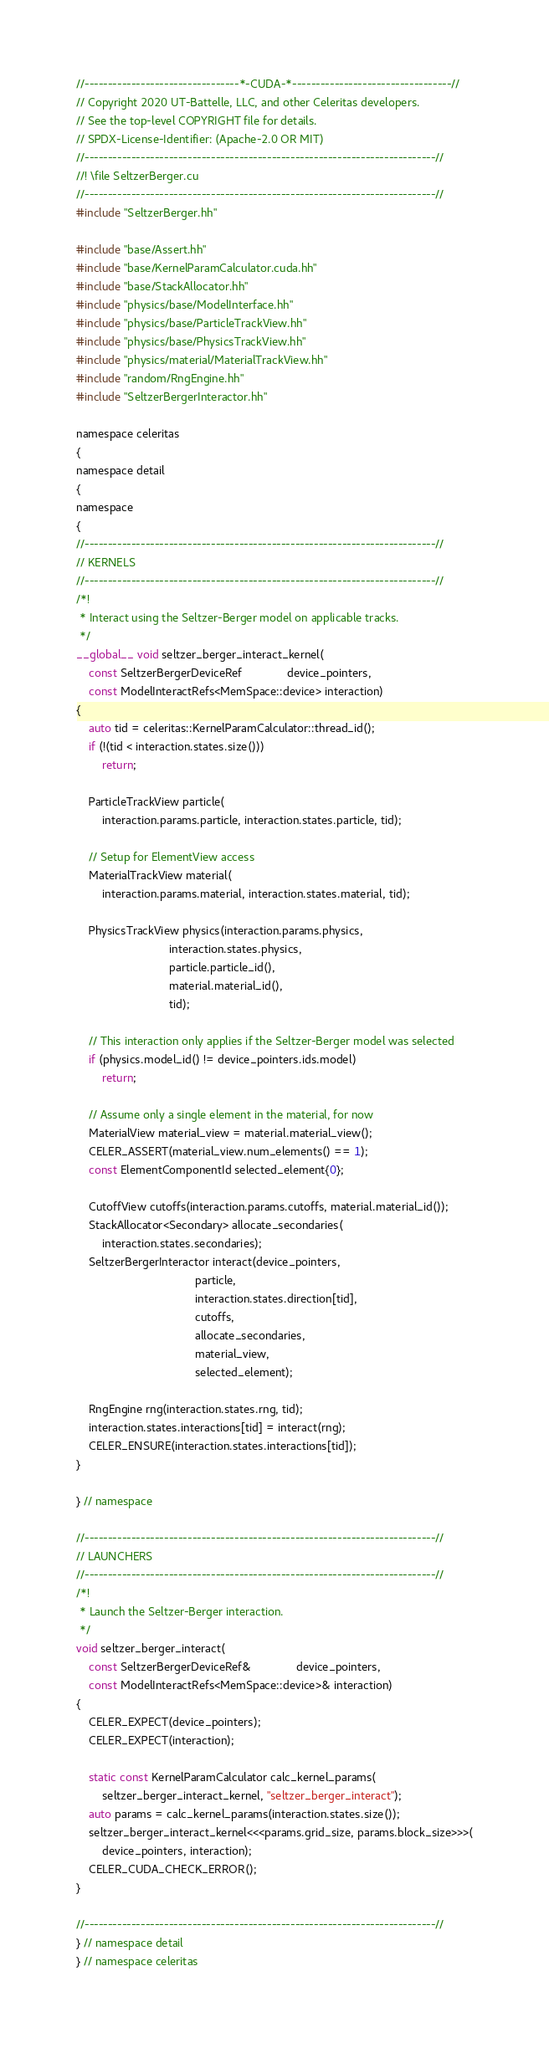<code> <loc_0><loc_0><loc_500><loc_500><_Cuda_>//---------------------------------*-CUDA-*----------------------------------//
// Copyright 2020 UT-Battelle, LLC, and other Celeritas developers.
// See the top-level COPYRIGHT file for details.
// SPDX-License-Identifier: (Apache-2.0 OR MIT)
//---------------------------------------------------------------------------//
//! \file SeltzerBerger.cu
//---------------------------------------------------------------------------//
#include "SeltzerBerger.hh"

#include "base/Assert.hh"
#include "base/KernelParamCalculator.cuda.hh"
#include "base/StackAllocator.hh"
#include "physics/base/ModelInterface.hh"
#include "physics/base/ParticleTrackView.hh"
#include "physics/base/PhysicsTrackView.hh"
#include "physics/material/MaterialTrackView.hh"
#include "random/RngEngine.hh"
#include "SeltzerBergerInteractor.hh"

namespace celeritas
{
namespace detail
{
namespace
{
//---------------------------------------------------------------------------//
// KERNELS
//---------------------------------------------------------------------------//
/*!
 * Interact using the Seltzer-Berger model on applicable tracks.
 */
__global__ void seltzer_berger_interact_kernel(
    const SeltzerBergerDeviceRef              device_pointers,
    const ModelInteractRefs<MemSpace::device> interaction)
{
    auto tid = celeritas::KernelParamCalculator::thread_id();
    if (!(tid < interaction.states.size()))
        return;

    ParticleTrackView particle(
        interaction.params.particle, interaction.states.particle, tid);

    // Setup for ElementView access
    MaterialTrackView material(
        interaction.params.material, interaction.states.material, tid);

    PhysicsTrackView physics(interaction.params.physics,
                             interaction.states.physics,
                             particle.particle_id(),
                             material.material_id(),
                             tid);

    // This interaction only applies if the Seltzer-Berger model was selected
    if (physics.model_id() != device_pointers.ids.model)
        return;

    // Assume only a single element in the material, for now
    MaterialView material_view = material.material_view();
    CELER_ASSERT(material_view.num_elements() == 1);
    const ElementComponentId selected_element{0};

    CutoffView cutoffs(interaction.params.cutoffs, material.material_id());
    StackAllocator<Secondary> allocate_secondaries(
        interaction.states.secondaries);
    SeltzerBergerInteractor interact(device_pointers,
                                     particle,
                                     interaction.states.direction[tid],
                                     cutoffs,
                                     allocate_secondaries,
                                     material_view,
                                     selected_element);

    RngEngine rng(interaction.states.rng, tid);
    interaction.states.interactions[tid] = interact(rng);
    CELER_ENSURE(interaction.states.interactions[tid]);
}

} // namespace

//---------------------------------------------------------------------------//
// LAUNCHERS
//---------------------------------------------------------------------------//
/*!
 * Launch the Seltzer-Berger interaction.
 */
void seltzer_berger_interact(
    const SeltzerBergerDeviceRef&              device_pointers,
    const ModelInteractRefs<MemSpace::device>& interaction)
{
    CELER_EXPECT(device_pointers);
    CELER_EXPECT(interaction);

    static const KernelParamCalculator calc_kernel_params(
        seltzer_berger_interact_kernel, "seltzer_berger_interact");
    auto params = calc_kernel_params(interaction.states.size());
    seltzer_berger_interact_kernel<<<params.grid_size, params.block_size>>>(
        device_pointers, interaction);
    CELER_CUDA_CHECK_ERROR();
}

//---------------------------------------------------------------------------//
} // namespace detail
} // namespace celeritas
</code> 